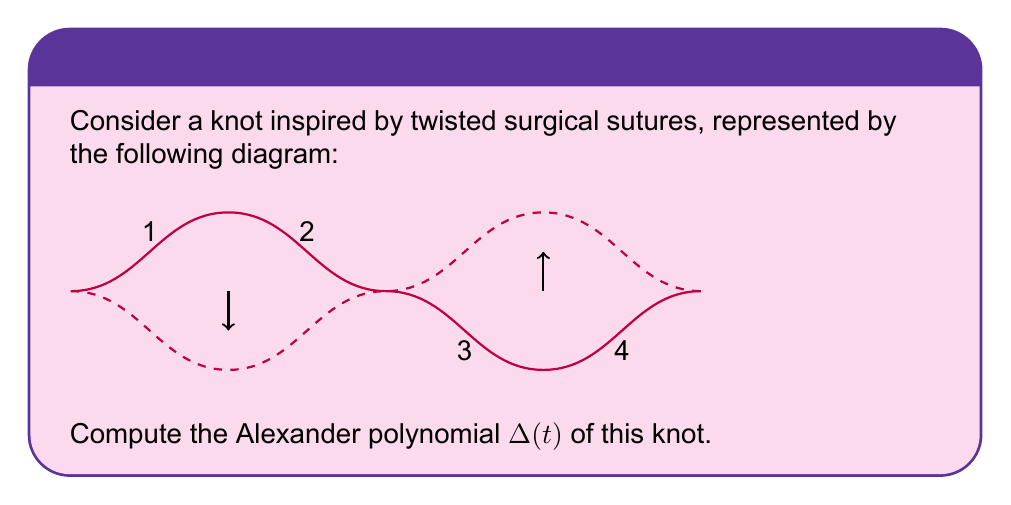Help me with this question. To compute the Alexander polynomial of this knot, we'll follow these steps:

1) First, we need to label the arcs and crossings. We've already labeled the crossings 1-4 in the diagram.

2) Now, we'll create the Alexander matrix. For each crossing, we'll have a row in the matrix. The columns correspond to the arcs.

3) For a positive crossing (like 1 and 2), we use the relation: $-t$ (under-arc coming in) + $(1-t)$ (over-arc) + $t$ (under-arc going out) = 0
   For a negative crossing (like 3 and 4), we use: $-1$ (under-arc coming in) + $(1-t)$ (over-arc) + $t$ (under-arc going out) = 0

4) Our Alexander matrix will be:

   $$\begin{pmatrix}
   1-t & -t & t & 0 \\
   0 & 1-t & -t & t \\
   -1 & t & 1-t & 0 \\
   t & -1 & 0 & 1-t
   \end{pmatrix}$$

5) The Alexander polynomial is the determinant of any 3x3 minor of this matrix, divided by $(t-1)^{n-1}$ where $n$ is the number of crossings.

6) Let's choose the minor formed by deleting the last column:

   $$\begin{vmatrix}
   1-t & -t & t \\
   0 & 1-t & -t \\
   -1 & t & 1-t
   \end{vmatrix}$$

7) Calculating this determinant:
   $$(1-t)((1-t)(1-t) - t^2) - (-t)(0 - (-t)(-1)) + t(-1(1-t) - 0)$$
   $$= (1-t)(1-2t+t^2-t^2) + t^2(-1) + t(-1+t)$$
   $$= (1-t)(1-2t) - t^2 + t(-1+t)$$
   $$= 1-2t-t+2t^2 - t^2 + -t+t^2$$
   $$= 1-3t+2t^2$$

8) We divide this by $(t-1)^{4-1} = (t-1)^3$:

   $$\frac{1-3t+2t^2}{(t-1)^3} = \frac{1-3t+2t^2}{-1+3t-3t^2+t^3}$$

9) Multiplying both numerator and denominator by -1 to make the constant term positive:

   $$\frac{-1+3t-2t^2}{1-3t+3t^2-t^3}$$

This is the Alexander polynomial of the knot.
Answer: $$\Delta(t) = \frac{-1+3t-2t^2}{1-3t+3t^2-t^3}$$ 